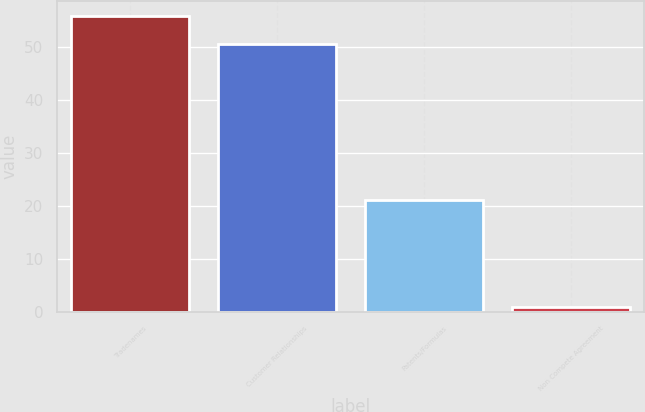Convert chart to OTSL. <chart><loc_0><loc_0><loc_500><loc_500><bar_chart><fcel>Tradenames<fcel>Customer Relationships<fcel>Patents/Formulas<fcel>Non Compete Agreement<nl><fcel>55.79<fcel>50.5<fcel>21<fcel>1<nl></chart> 